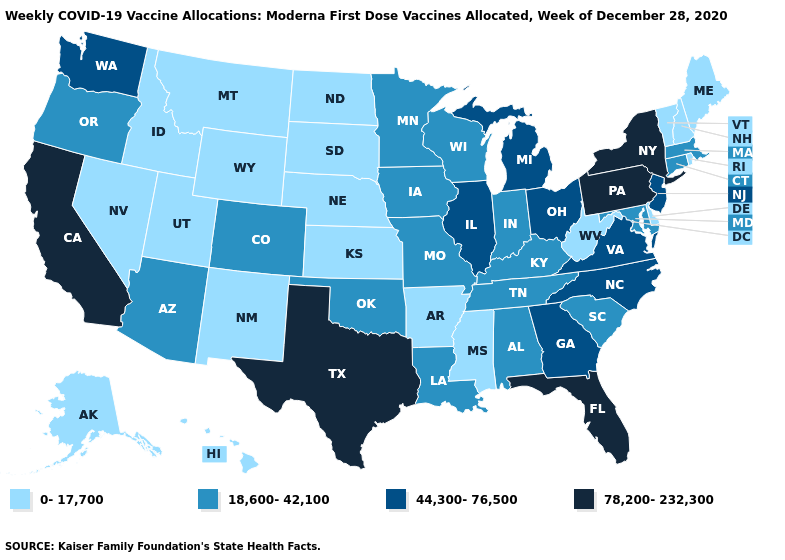Among the states that border Louisiana , which have the highest value?
Be succinct. Texas. How many symbols are there in the legend?
Keep it brief. 4. Name the states that have a value in the range 78,200-232,300?
Be succinct. California, Florida, New York, Pennsylvania, Texas. Name the states that have a value in the range 78,200-232,300?
Quick response, please. California, Florida, New York, Pennsylvania, Texas. Which states have the highest value in the USA?
Concise answer only. California, Florida, New York, Pennsylvania, Texas. Which states have the lowest value in the Northeast?
Quick response, please. Maine, New Hampshire, Rhode Island, Vermont. Does Indiana have the highest value in the MidWest?
Be succinct. No. Name the states that have a value in the range 18,600-42,100?
Short answer required. Alabama, Arizona, Colorado, Connecticut, Indiana, Iowa, Kentucky, Louisiana, Maryland, Massachusetts, Minnesota, Missouri, Oklahoma, Oregon, South Carolina, Tennessee, Wisconsin. Does South Carolina have the highest value in the South?
Concise answer only. No. Name the states that have a value in the range 78,200-232,300?
Write a very short answer. California, Florida, New York, Pennsylvania, Texas. What is the value of Connecticut?
Write a very short answer. 18,600-42,100. Does Kentucky have the same value as Florida?
Write a very short answer. No. How many symbols are there in the legend?
Short answer required. 4. Among the states that border Oregon , does Washington have the lowest value?
Keep it brief. No. Which states have the lowest value in the Northeast?
Be succinct. Maine, New Hampshire, Rhode Island, Vermont. 